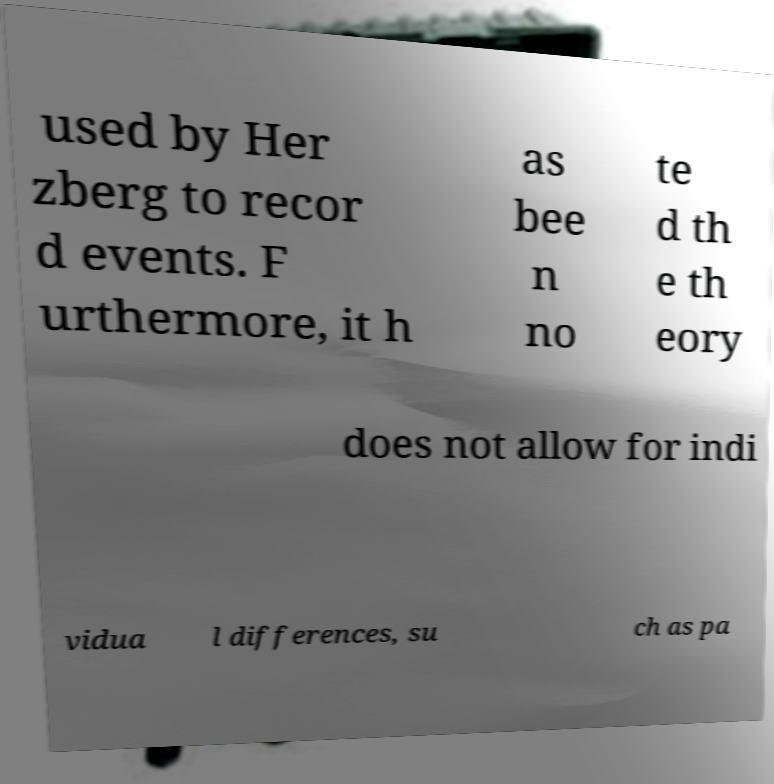I need the written content from this picture converted into text. Can you do that? used by Her zberg to recor d events. F urthermore, it h as bee n no te d th e th eory does not allow for indi vidua l differences, su ch as pa 